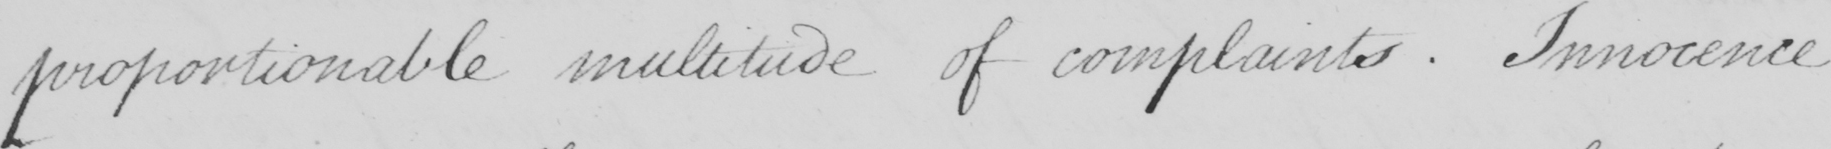What does this handwritten line say? proportionable multitude of complaints . Innocence 